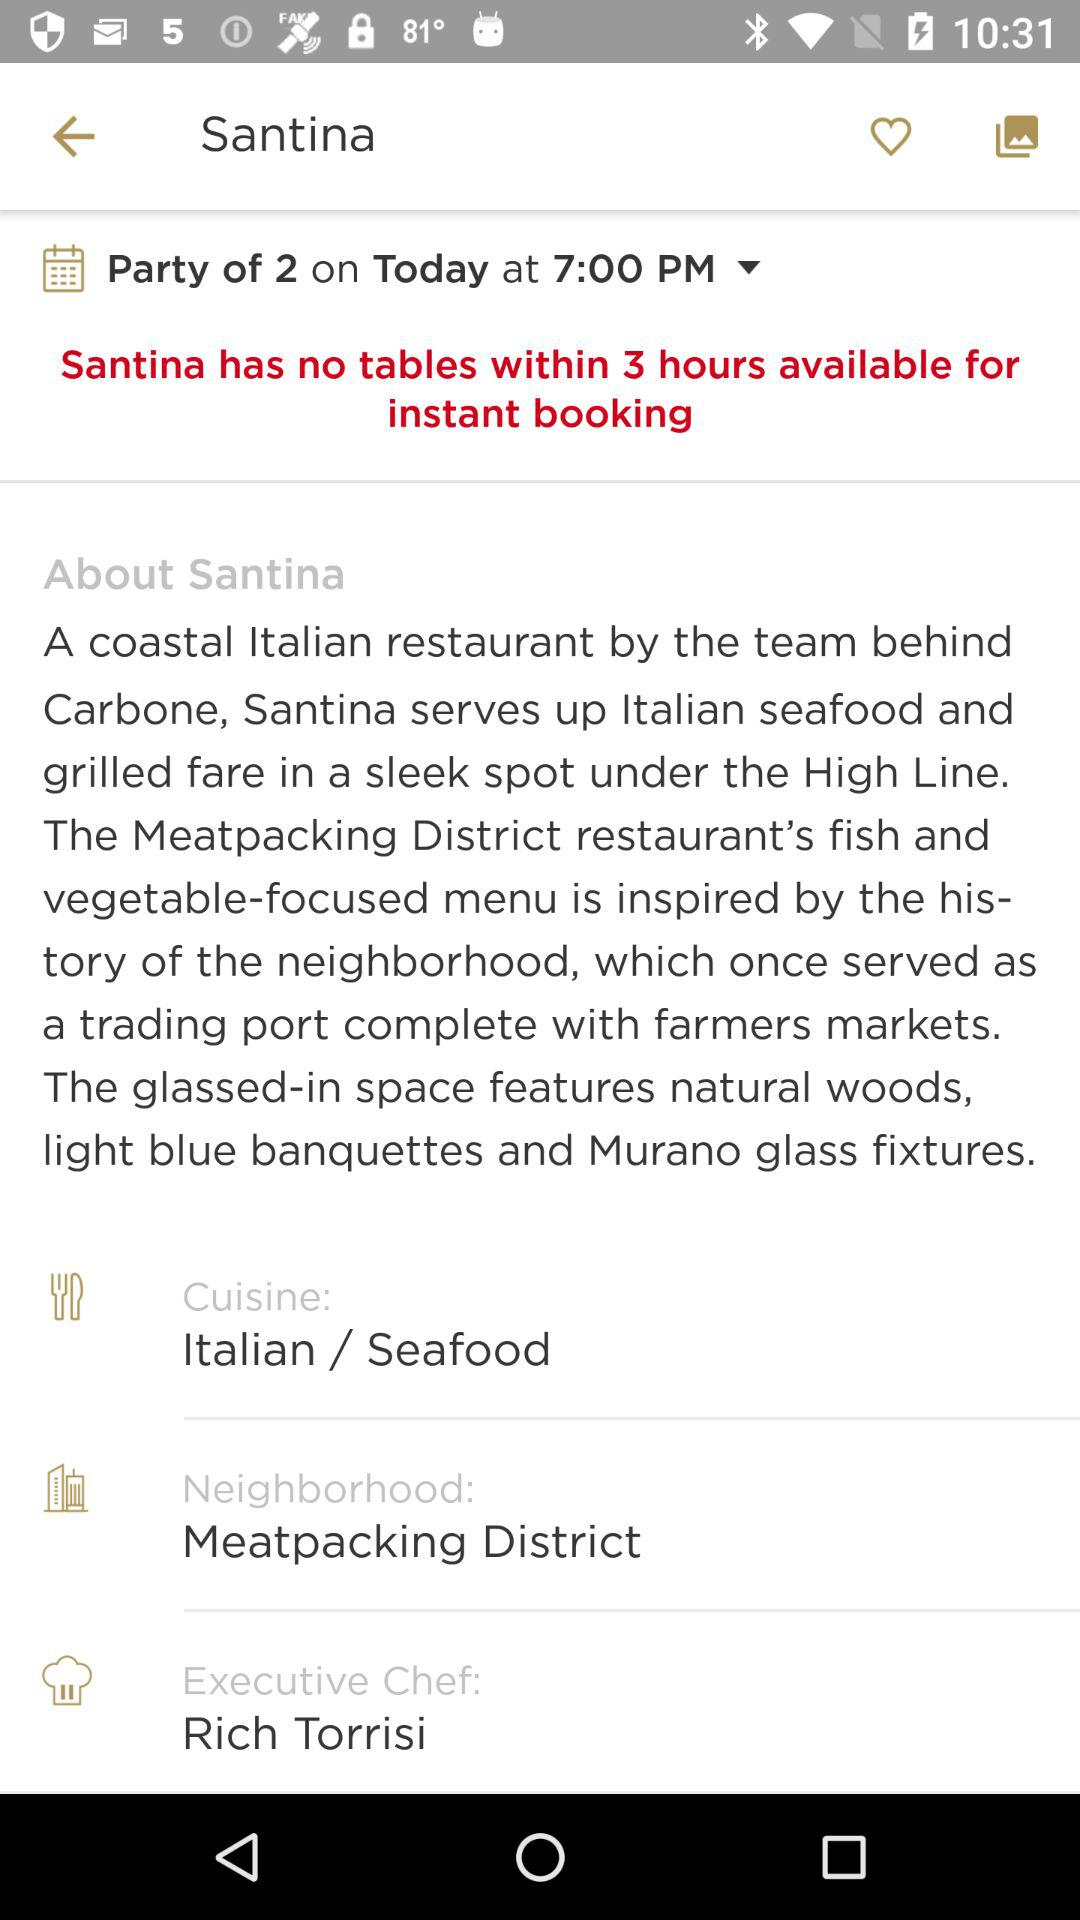Who is the executive chef? The executive chef is Rich Torrisi. 